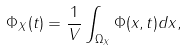<formula> <loc_0><loc_0><loc_500><loc_500>\Phi _ { X } ( t ) = \frac { 1 } { V } \int _ { \Omega _ { X } } \Phi ( x , t ) d x ,</formula> 